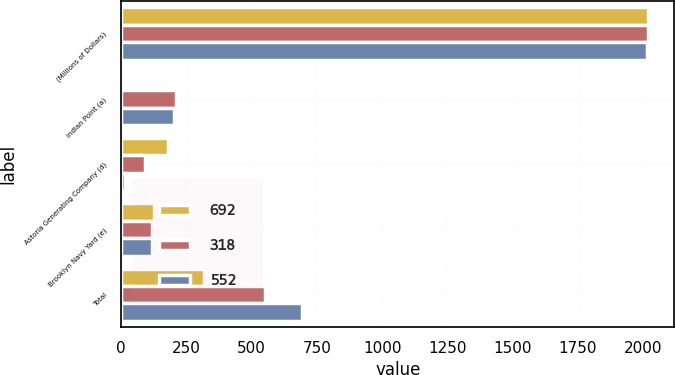Convert chart. <chart><loc_0><loc_0><loc_500><loc_500><stacked_bar_chart><ecel><fcel>(Millions of Dollars)<fcel>Indian Point (a)<fcel>Astoria Generating Company (d)<fcel>Brooklyn Navy Yard (e)<fcel>Total<nl><fcel>692<fcel>2018<fcel>6<fcel>179<fcel>124<fcel>318<nl><fcel>318<fcel>2017<fcel>211<fcel>92<fcel>117<fcel>552<nl><fcel>552<fcel>2016<fcel>203<fcel>16<fcel>119<fcel>692<nl></chart> 